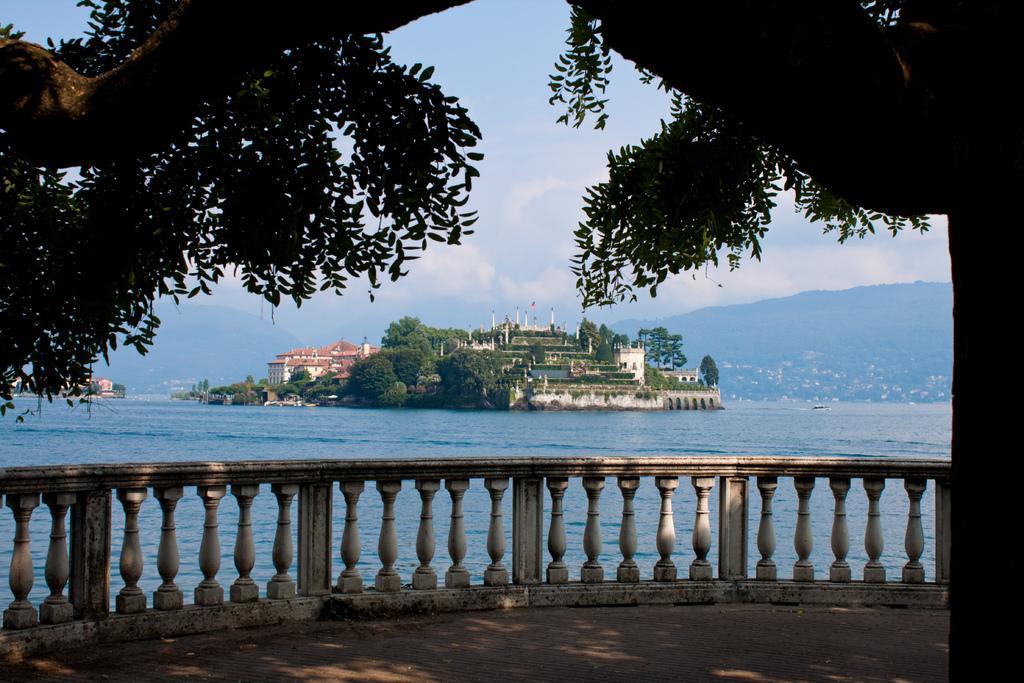Could you give a brief overview of what you see in this image? In this image I can see the railing. To the side of the railing I can see the water, trees and the building which is in brown color. To the right I can see the big tree. In the back there are mountains, clouds and the blue sky. 